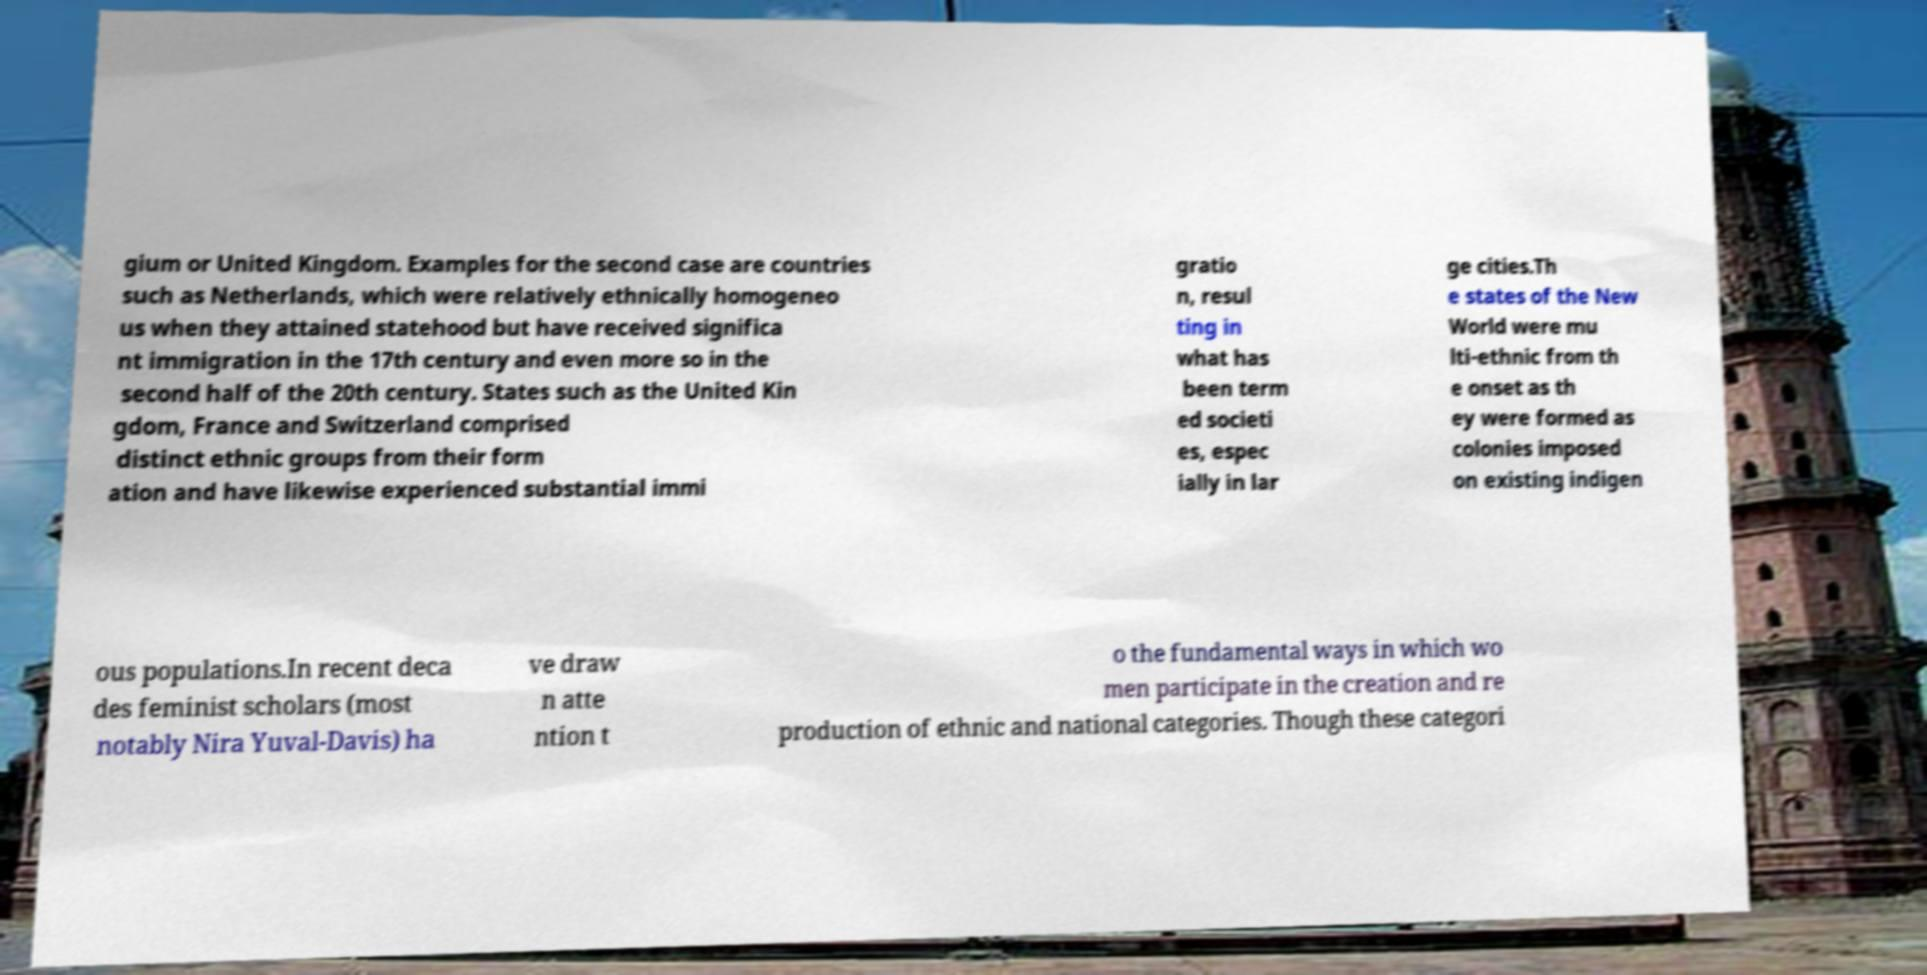Can you read and provide the text displayed in the image?This photo seems to have some interesting text. Can you extract and type it out for me? gium or United Kingdom. Examples for the second case are countries such as Netherlands, which were relatively ethnically homogeneo us when they attained statehood but have received significa nt immigration in the 17th century and even more so in the second half of the 20th century. States such as the United Kin gdom, France and Switzerland comprised distinct ethnic groups from their form ation and have likewise experienced substantial immi gratio n, resul ting in what has been term ed societi es, espec ially in lar ge cities.Th e states of the New World were mu lti-ethnic from th e onset as th ey were formed as colonies imposed on existing indigen ous populations.In recent deca des feminist scholars (most notably Nira Yuval-Davis) ha ve draw n atte ntion t o the fundamental ways in which wo men participate in the creation and re production of ethnic and national categories. Though these categori 